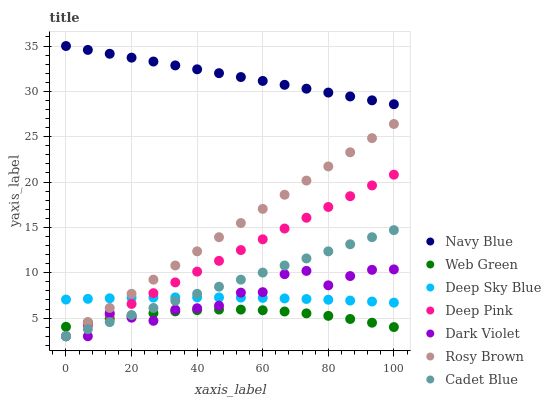Does Web Green have the minimum area under the curve?
Answer yes or no. Yes. Does Navy Blue have the maximum area under the curve?
Answer yes or no. Yes. Does Rosy Brown have the minimum area under the curve?
Answer yes or no. No. Does Rosy Brown have the maximum area under the curve?
Answer yes or no. No. Is Cadet Blue the smoothest?
Answer yes or no. Yes. Is Dark Violet the roughest?
Answer yes or no. Yes. Is Navy Blue the smoothest?
Answer yes or no. No. Is Navy Blue the roughest?
Answer yes or no. No. Does Deep Pink have the lowest value?
Answer yes or no. Yes. Does Navy Blue have the lowest value?
Answer yes or no. No. Does Navy Blue have the highest value?
Answer yes or no. Yes. Does Rosy Brown have the highest value?
Answer yes or no. No. Is Web Green less than Deep Sky Blue?
Answer yes or no. Yes. Is Deep Sky Blue greater than Web Green?
Answer yes or no. Yes. Does Web Green intersect Cadet Blue?
Answer yes or no. Yes. Is Web Green less than Cadet Blue?
Answer yes or no. No. Is Web Green greater than Cadet Blue?
Answer yes or no. No. Does Web Green intersect Deep Sky Blue?
Answer yes or no. No. 